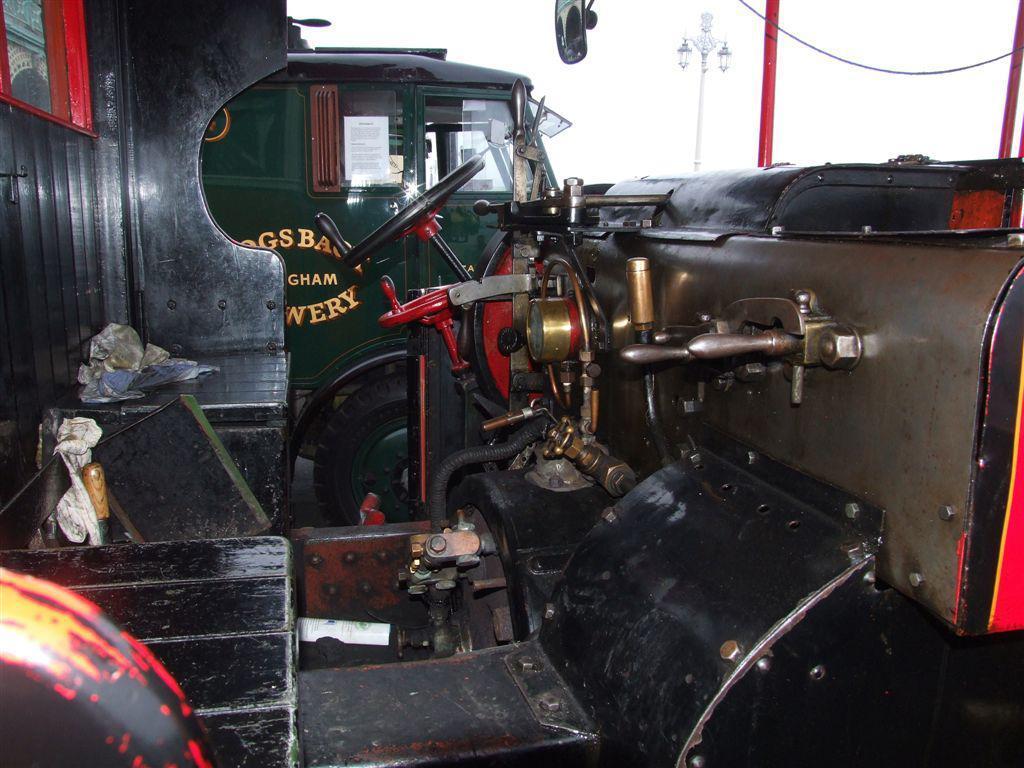Describe this image in one or two sentences. In this image there are vehicles in the center. On the right side there are poles and the sky is cloudy. 